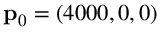<formula> <loc_0><loc_0><loc_500><loc_500>p _ { 0 } = ( 4 0 0 0 , 0 , 0 )</formula> 